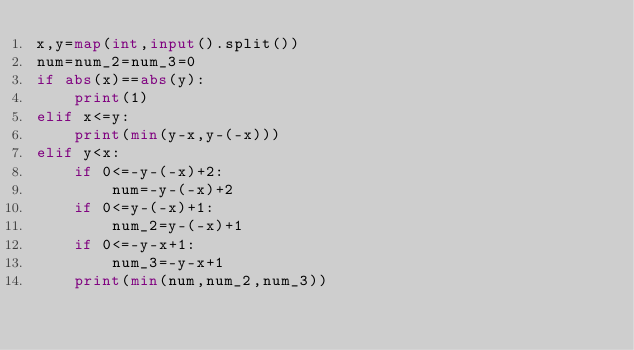Convert code to text. <code><loc_0><loc_0><loc_500><loc_500><_Python_>x,y=map(int,input().split())
num=num_2=num_3=0
if abs(x)==abs(y):
    print(1)
elif x<=y:
    print(min(y-x,y-(-x)))
elif y<x:
    if 0<=-y-(-x)+2:
        num=-y-(-x)+2
    if 0<=y-(-x)+1:
        num_2=y-(-x)+1
    if 0<=-y-x+1:
        num_3=-y-x+1
    print(min(num,num_2,num_3))
</code> 